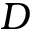<formula> <loc_0><loc_0><loc_500><loc_500>D</formula> 